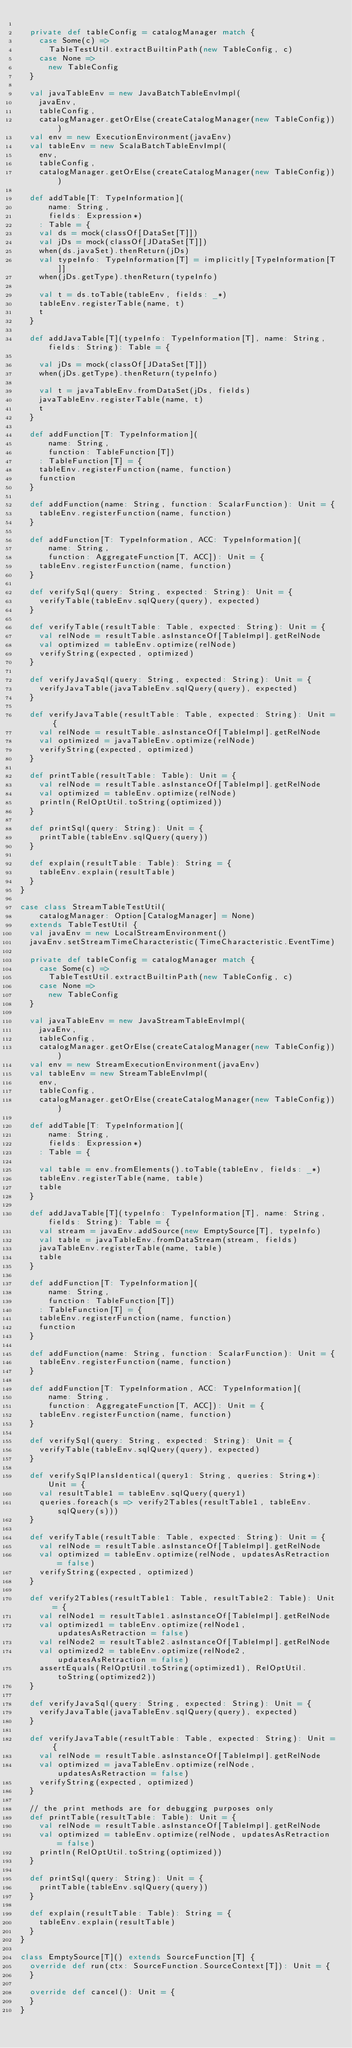<code> <loc_0><loc_0><loc_500><loc_500><_Scala_>
  private def tableConfig = catalogManager match {
    case Some(c) =>
      TableTestUtil.extractBuiltinPath(new TableConfig, c)
    case None =>
      new TableConfig
  }

  val javaTableEnv = new JavaBatchTableEnvImpl(
    javaEnv,
    tableConfig,
    catalogManager.getOrElse(createCatalogManager(new TableConfig)))
  val env = new ExecutionEnvironment(javaEnv)
  val tableEnv = new ScalaBatchTableEnvImpl(
    env,
    tableConfig,
    catalogManager.getOrElse(createCatalogManager(new TableConfig)))

  def addTable[T: TypeInformation](
      name: String,
      fields: Expression*)
    : Table = {
    val ds = mock(classOf[DataSet[T]])
    val jDs = mock(classOf[JDataSet[T]])
    when(ds.javaSet).thenReturn(jDs)
    val typeInfo: TypeInformation[T] = implicitly[TypeInformation[T]]
    when(jDs.getType).thenReturn(typeInfo)

    val t = ds.toTable(tableEnv, fields: _*)
    tableEnv.registerTable(name, t)
    t
  }

  def addJavaTable[T](typeInfo: TypeInformation[T], name: String, fields: String): Table = {

    val jDs = mock(classOf[JDataSet[T]])
    when(jDs.getType).thenReturn(typeInfo)

    val t = javaTableEnv.fromDataSet(jDs, fields)
    javaTableEnv.registerTable(name, t)
    t
  }

  def addFunction[T: TypeInformation](
      name: String,
      function: TableFunction[T])
    : TableFunction[T] = {
    tableEnv.registerFunction(name, function)
    function
  }

  def addFunction(name: String, function: ScalarFunction): Unit = {
    tableEnv.registerFunction(name, function)
  }

  def addFunction[T: TypeInformation, ACC: TypeInformation](
      name: String,
      function: AggregateFunction[T, ACC]): Unit = {
    tableEnv.registerFunction(name, function)
  }

  def verifySql(query: String, expected: String): Unit = {
    verifyTable(tableEnv.sqlQuery(query), expected)
  }

  def verifyTable(resultTable: Table, expected: String): Unit = {
    val relNode = resultTable.asInstanceOf[TableImpl].getRelNode
    val optimized = tableEnv.optimize(relNode)
    verifyString(expected, optimized)
  }

  def verifyJavaSql(query: String, expected: String): Unit = {
    verifyJavaTable(javaTableEnv.sqlQuery(query), expected)
  }

  def verifyJavaTable(resultTable: Table, expected: String): Unit = {
    val relNode = resultTable.asInstanceOf[TableImpl].getRelNode
    val optimized = javaTableEnv.optimize(relNode)
    verifyString(expected, optimized)
  }

  def printTable(resultTable: Table): Unit = {
    val relNode = resultTable.asInstanceOf[TableImpl].getRelNode
    val optimized = tableEnv.optimize(relNode)
    println(RelOptUtil.toString(optimized))
  }

  def printSql(query: String): Unit = {
    printTable(tableEnv.sqlQuery(query))
  }

  def explain(resultTable: Table): String = {
    tableEnv.explain(resultTable)
  }
}

case class StreamTableTestUtil(
    catalogManager: Option[CatalogManager] = None)
  extends TableTestUtil {
  val javaEnv = new LocalStreamEnvironment()
  javaEnv.setStreamTimeCharacteristic(TimeCharacteristic.EventTime)

  private def tableConfig = catalogManager match {
    case Some(c) =>
      TableTestUtil.extractBuiltinPath(new TableConfig, c)
    case None =>
      new TableConfig
  }

  val javaTableEnv = new JavaStreamTableEnvImpl(
    javaEnv,
    tableConfig,
    catalogManager.getOrElse(createCatalogManager(new TableConfig)))
  val env = new StreamExecutionEnvironment(javaEnv)
  val tableEnv = new StreamTableEnvImpl(
    env,
    tableConfig,
    catalogManager.getOrElse(createCatalogManager(new TableConfig)))

  def addTable[T: TypeInformation](
      name: String,
      fields: Expression*)
    : Table = {

    val table = env.fromElements().toTable(tableEnv, fields: _*)
    tableEnv.registerTable(name, table)
    table
  }

  def addJavaTable[T](typeInfo: TypeInformation[T], name: String, fields: String): Table = {
    val stream = javaEnv.addSource(new EmptySource[T], typeInfo)
    val table = javaTableEnv.fromDataStream(stream, fields)
    javaTableEnv.registerTable(name, table)
    table
  }

  def addFunction[T: TypeInformation](
      name: String,
      function: TableFunction[T])
    : TableFunction[T] = {
    tableEnv.registerFunction(name, function)
    function
  }

  def addFunction(name: String, function: ScalarFunction): Unit = {
    tableEnv.registerFunction(name, function)
  }

  def addFunction[T: TypeInformation, ACC: TypeInformation](
      name: String,
      function: AggregateFunction[T, ACC]): Unit = {
    tableEnv.registerFunction(name, function)
  }

  def verifySql(query: String, expected: String): Unit = {
    verifyTable(tableEnv.sqlQuery(query), expected)
  }

  def verifySqlPlansIdentical(query1: String, queries: String*): Unit = {
    val resultTable1 = tableEnv.sqlQuery(query1)
    queries.foreach(s => verify2Tables(resultTable1, tableEnv.sqlQuery(s)))
  }

  def verifyTable(resultTable: Table, expected: String): Unit = {
    val relNode = resultTable.asInstanceOf[TableImpl].getRelNode
    val optimized = tableEnv.optimize(relNode, updatesAsRetraction = false)
    verifyString(expected, optimized)
  }

  def verify2Tables(resultTable1: Table, resultTable2: Table): Unit = {
    val relNode1 = resultTable1.asInstanceOf[TableImpl].getRelNode
    val optimized1 = tableEnv.optimize(relNode1, updatesAsRetraction = false)
    val relNode2 = resultTable2.asInstanceOf[TableImpl].getRelNode
    val optimized2 = tableEnv.optimize(relNode2, updatesAsRetraction = false)
    assertEquals(RelOptUtil.toString(optimized1), RelOptUtil.toString(optimized2))
  }

  def verifyJavaSql(query: String, expected: String): Unit = {
    verifyJavaTable(javaTableEnv.sqlQuery(query), expected)
  }

  def verifyJavaTable(resultTable: Table, expected: String): Unit = {
    val relNode = resultTable.asInstanceOf[TableImpl].getRelNode
    val optimized = javaTableEnv.optimize(relNode, updatesAsRetraction = false)
    verifyString(expected, optimized)
  }

  // the print methods are for debugging purposes only
  def printTable(resultTable: Table): Unit = {
    val relNode = resultTable.asInstanceOf[TableImpl].getRelNode
    val optimized = tableEnv.optimize(relNode, updatesAsRetraction = false)
    println(RelOptUtil.toString(optimized))
  }

  def printSql(query: String): Unit = {
    printTable(tableEnv.sqlQuery(query))
  }

  def explain(resultTable: Table): String = {
    tableEnv.explain(resultTable)
  }
}

class EmptySource[T]() extends SourceFunction[T] {
  override def run(ctx: SourceFunction.SourceContext[T]): Unit = {
  }

  override def cancel(): Unit = {
  }
}
</code> 